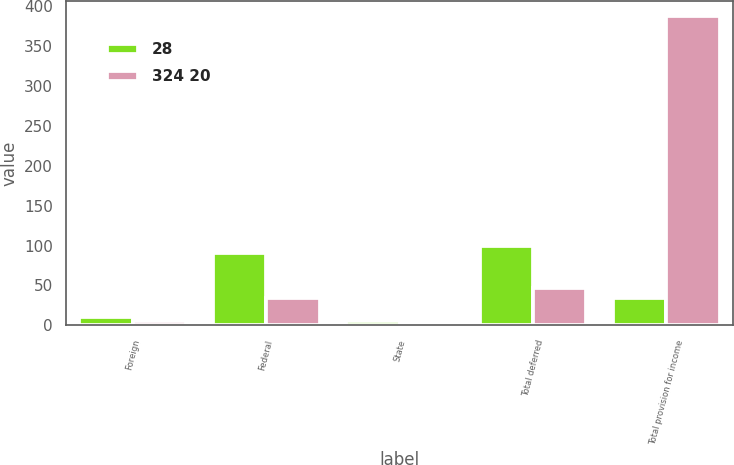<chart> <loc_0><loc_0><loc_500><loc_500><stacked_bar_chart><ecel><fcel>Foreign<fcel>Federal<fcel>State<fcel>Total deferred<fcel>Total provision for income<nl><fcel>28<fcel>10<fcel>91<fcel>6<fcel>99<fcel>34<nl><fcel>324 20<fcel>5<fcel>34<fcel>2<fcel>47<fcel>387<nl></chart> 